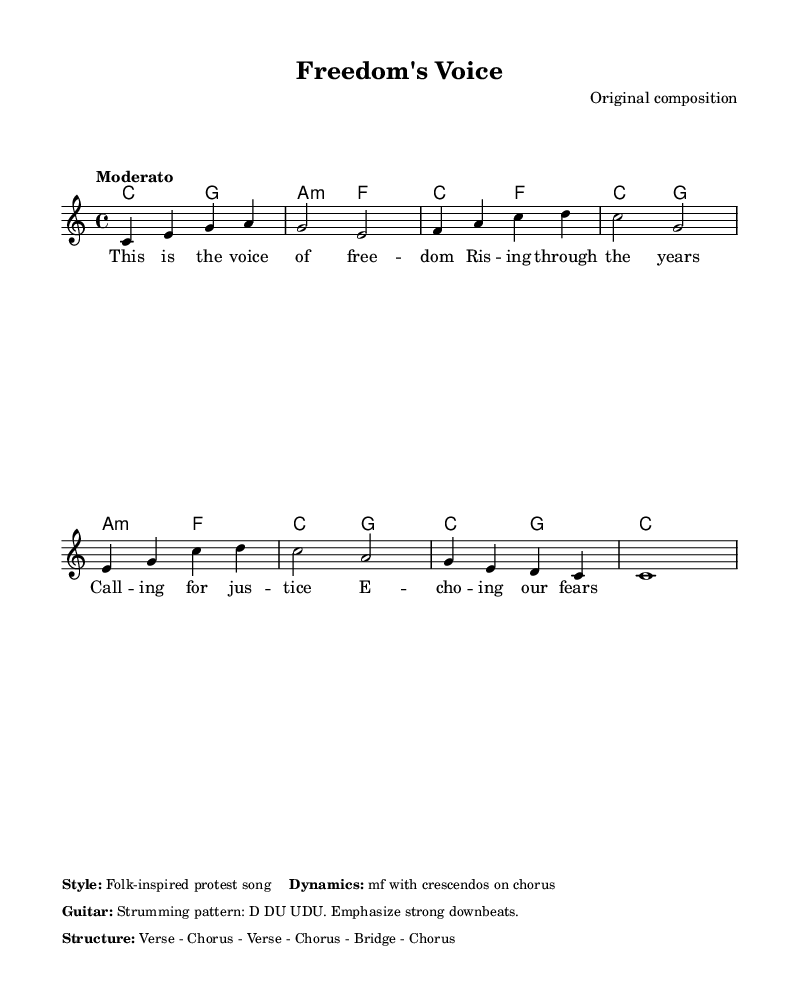What is the time signature of this music? The time signature is found at the beginning of the score, indicated as 4/4. This means there are four beats in each measure and the quarter note gets one beat.
Answer: 4/4 What key is this piece written in? The key signature at the beginning of the score indicates that the piece is in C major, which has no sharps or flats.
Answer: C major What is the tempo marking for this song? The tempo is described in the score as "Moderato," suggesting a moderate speed. This is typically around 108-120 beats per minute.
Answer: Moderato How many verses are in the song structure? The structure outlined in the score is "Verse - Chorus - Verse - Chorus - Bridge - Chorus," which includes two verses.
Answer: 2 What is the dynamic marking indicated for the song? The score includes a note stating "mf with crescendos on chorus," which indicates the dynamics are marked as mezzo forte with gradually increasing volume during the chorus.
Answer: mf What type of song is depicted by this sheet music? The style noted in the score references a "Folk-inspired protest song," which identifies the genre and thematic elements of the piece.
Answer: Folk-inspired protest song 